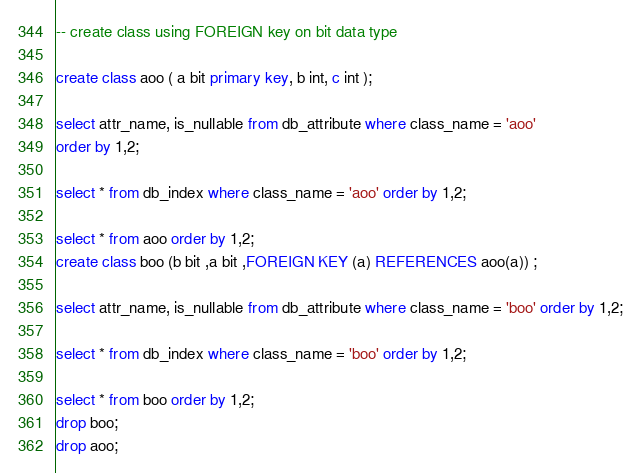<code> <loc_0><loc_0><loc_500><loc_500><_SQL_>-- create class using FOREIGN key on bit data type

create class aoo ( a bit primary key, b int, c int );

select attr_name, is_nullable from db_attribute where class_name = 'aoo'
order by 1,2;

select * from db_index where class_name = 'aoo' order by 1,2;

select * from aoo order by 1,2;
create class boo (b bit ,a bit ,FOREIGN KEY (a) REFERENCES aoo(a)) ;

select attr_name, is_nullable from db_attribute where class_name = 'boo' order by 1,2;

select * from db_index where class_name = 'boo' order by 1,2;

select * from boo order by 1,2;
drop boo;
drop aoo;</code> 